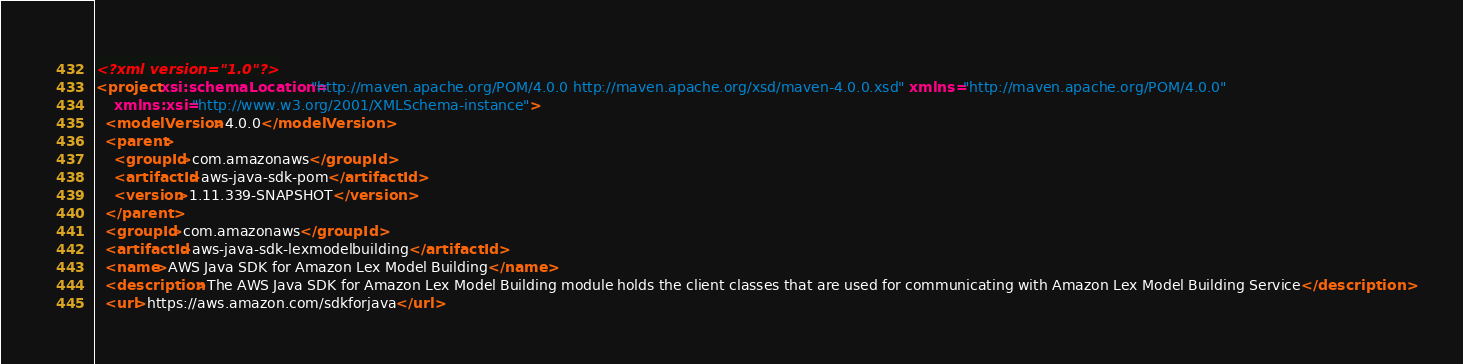<code> <loc_0><loc_0><loc_500><loc_500><_XML_><?xml version="1.0"?>
<project xsi:schemaLocation="http://maven.apache.org/POM/4.0.0 http://maven.apache.org/xsd/maven-4.0.0.xsd" xmlns="http://maven.apache.org/POM/4.0.0"
    xmlns:xsi="http://www.w3.org/2001/XMLSchema-instance">
  <modelVersion>4.0.0</modelVersion>
  <parent>
    <groupId>com.amazonaws</groupId>
    <artifactId>aws-java-sdk-pom</artifactId>
    <version>1.11.339-SNAPSHOT</version>
  </parent>
  <groupId>com.amazonaws</groupId>
  <artifactId>aws-java-sdk-lexmodelbuilding</artifactId>
  <name>AWS Java SDK for Amazon Lex Model Building</name>
  <description>The AWS Java SDK for Amazon Lex Model Building module holds the client classes that are used for communicating with Amazon Lex Model Building Service</description>
  <url>https://aws.amazon.com/sdkforjava</url>
</code> 